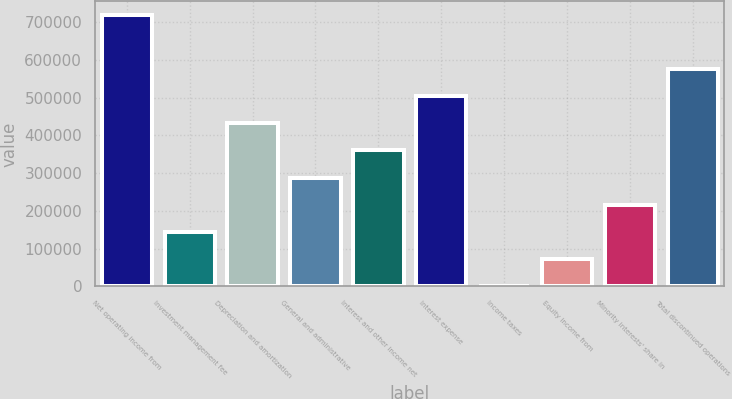<chart> <loc_0><loc_0><loc_500><loc_500><bar_chart><fcel>Net operating income from<fcel>Investment management fee<fcel>Depreciation and amortization<fcel>General and administrative<fcel>Interest and other income net<fcel>Interest expense<fcel>Income taxes<fcel>Equity income from<fcel>Minority interests' share in<fcel>Total discontinued operations<nl><fcel>718524<fcel>144873<fcel>431698<fcel>288286<fcel>359992<fcel>503405<fcel>1460<fcel>73166.4<fcel>216579<fcel>575111<nl></chart> 